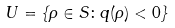Convert formula to latex. <formula><loc_0><loc_0><loc_500><loc_500>U = \{ \rho \in S \colon q ( \rho ) < 0 \}</formula> 